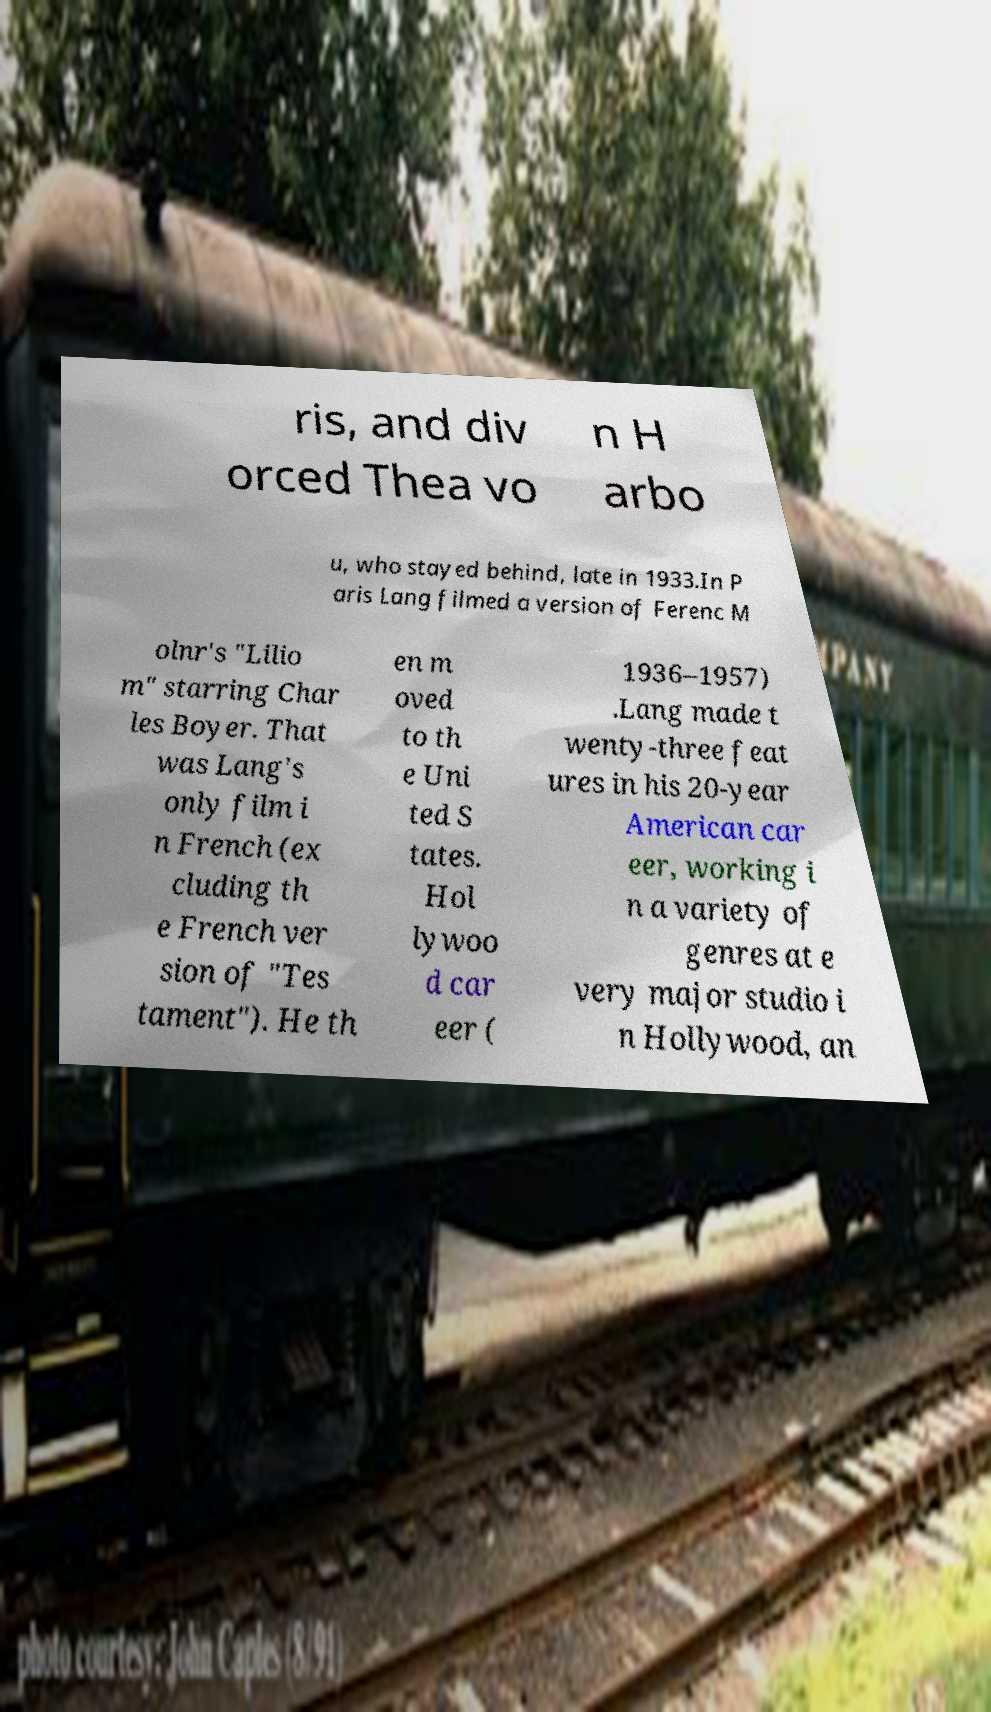What messages or text are displayed in this image? I need them in a readable, typed format. ris, and div orced Thea vo n H arbo u, who stayed behind, late in 1933.In P aris Lang filmed a version of Ferenc M olnr's "Lilio m" starring Char les Boyer. That was Lang's only film i n French (ex cluding th e French ver sion of "Tes tament"). He th en m oved to th e Uni ted S tates. Hol lywoo d car eer ( 1936–1957) .Lang made t wenty-three feat ures in his 20-year American car eer, working i n a variety of genres at e very major studio i n Hollywood, an 